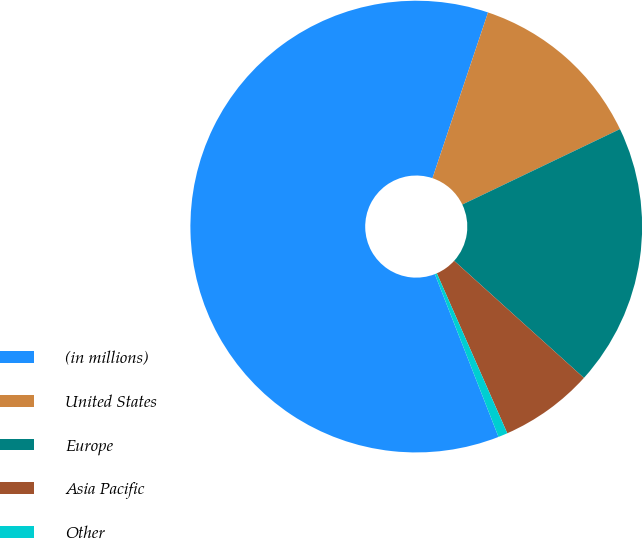Convert chart. <chart><loc_0><loc_0><loc_500><loc_500><pie_chart><fcel>(in millions)<fcel>United States<fcel>Europe<fcel>Asia Pacific<fcel>Other<nl><fcel>61.08%<fcel>12.75%<fcel>18.79%<fcel>6.71%<fcel>0.67%<nl></chart> 